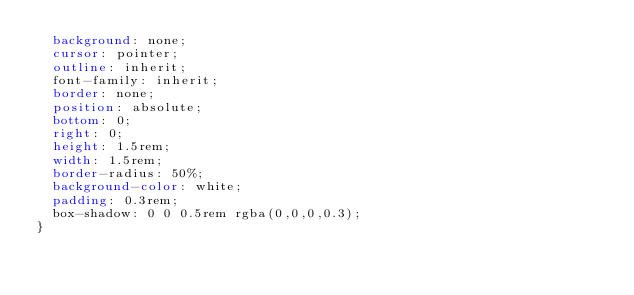<code> <loc_0><loc_0><loc_500><loc_500><_CSS_>  background: none;
  cursor: pointer;
  outline: inherit;
  font-family: inherit;
  border: none;
  position: absolute;
  bottom: 0;
  right: 0;
  height: 1.5rem;
  width: 1.5rem;
  border-radius: 50%;
  background-color: white;
  padding: 0.3rem;
  box-shadow: 0 0 0.5rem rgba(0,0,0,0.3);
}</code> 